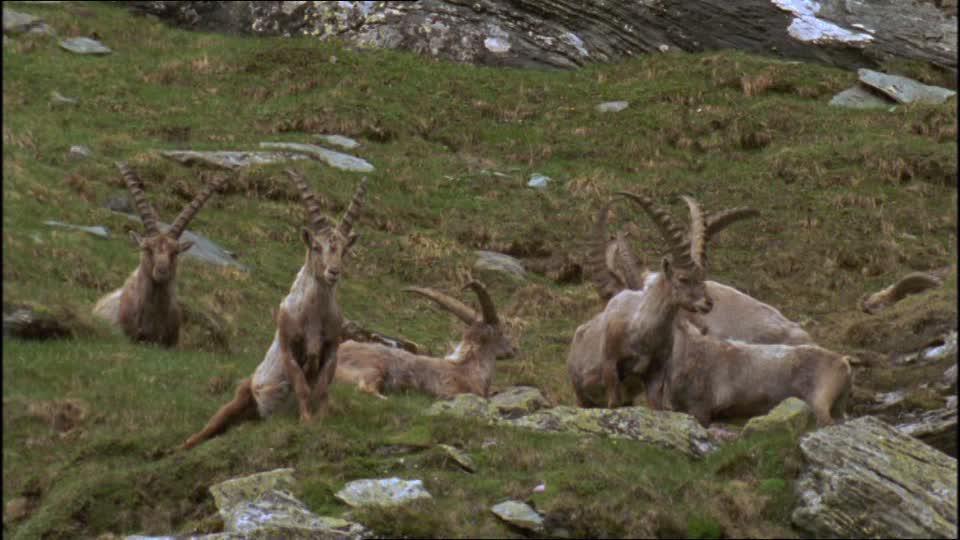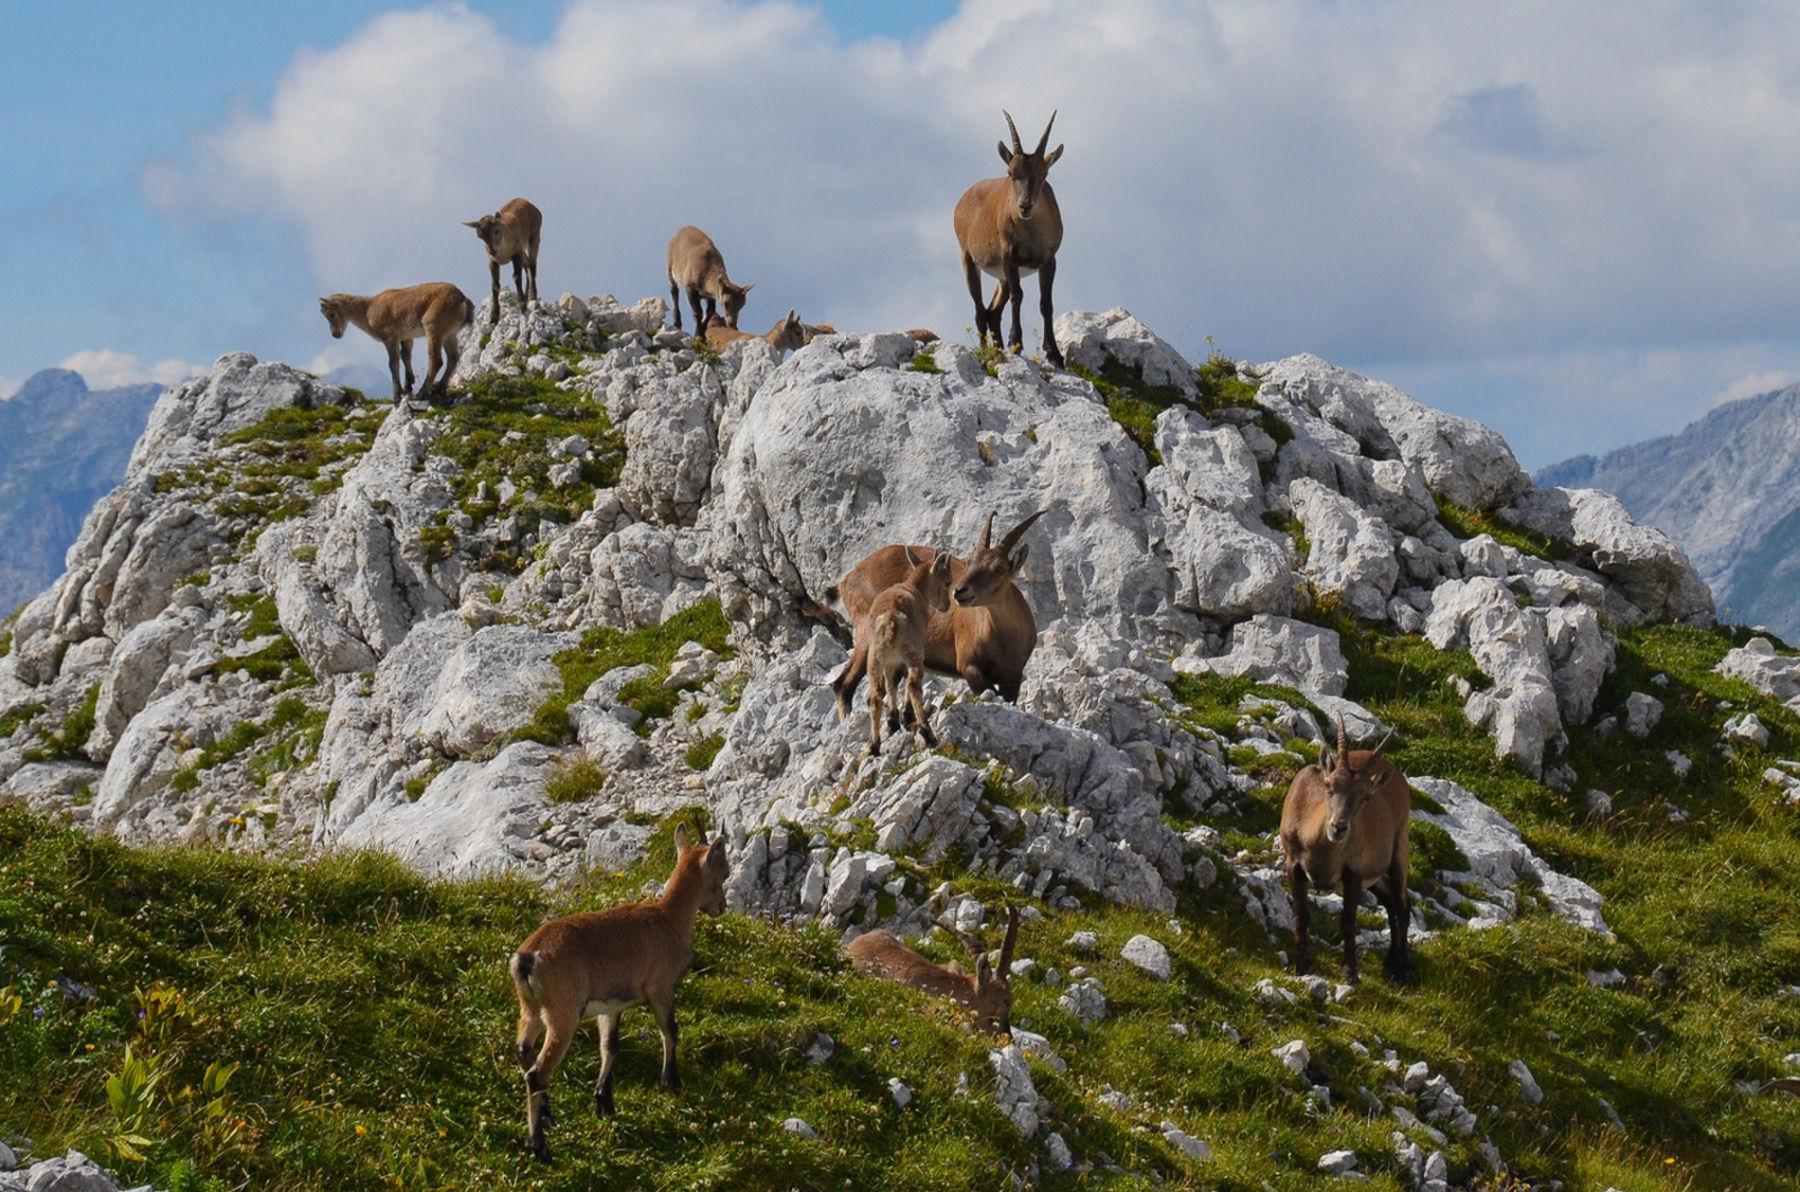The first image is the image on the left, the second image is the image on the right. Examine the images to the left and right. Is the description "One of the images contains a single animal." accurate? Answer yes or no. No. The first image is the image on the left, the second image is the image on the right. Analyze the images presented: Is the assertion "the image on the lft contains a single antelope" valid? Answer yes or no. No. 